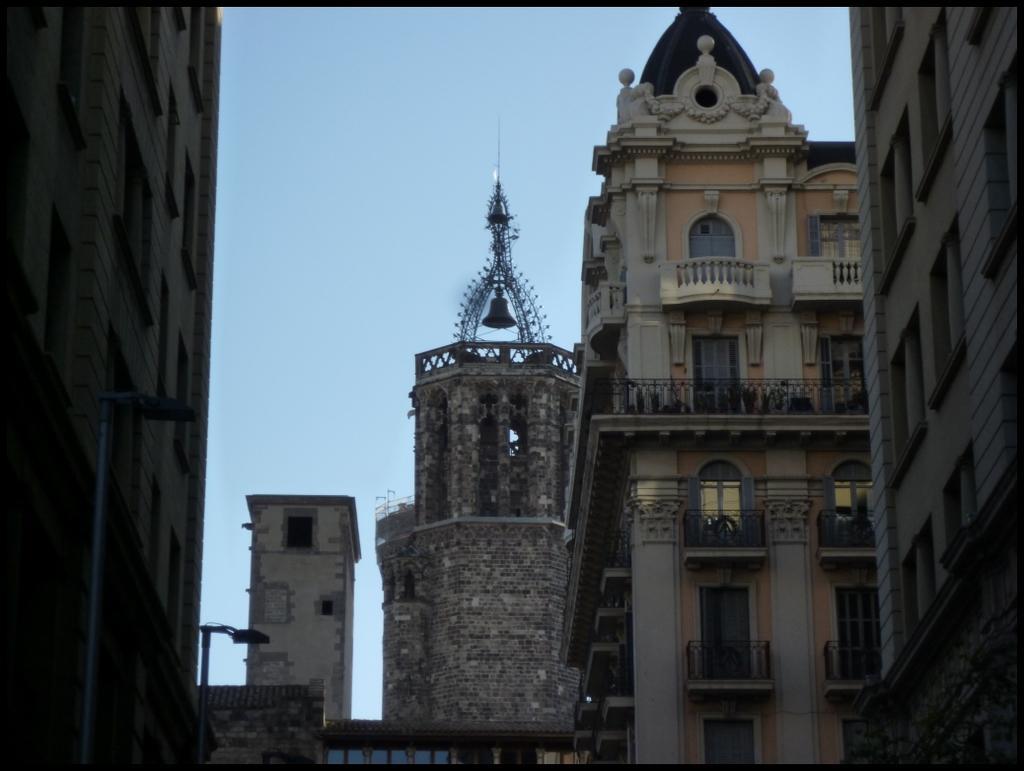Can you describe this image briefly? In the picture,there are many buildings one beside the other and they have a lot of windows and doors and in the background there is a sky. 